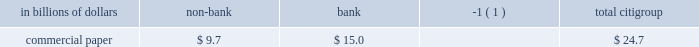Secured financing is primarily conducted through citi 2019s broker-dealer subsidiaries to facilitate customer matched-book activity and to efficiently fund a portion of the trading inventory .
Secured financing appears as a liability on citi 2019s consolidated balance sheet ( 201csecurities loaned or sold under agreements to repurchase 201d ) .
As of december 31 , 2010 , secured financing was $ 189.6 billion and averaged approximately $ 207 billion during the quarter ended december 31 , 2010 .
Secured financing at december 31 , 2010 increased by $ 35 billion from $ 154.3 billion at december 31 , 2009 .
During the same period , reverse repos and securities borrowing increased by $ 25 billion .
The majority of secured financing is collateralized by highly liquid government , government-backed and government agency securities .
This collateral comes primarily from citi 2019s trading assets and its secured lending , and is part of citi 2019s client matched-book activity given that citi both borrows and lends similar asset types on a secured basis .
The minority of secured financing is collateralized by less liquid collateral , and supports both citi 2019s trading assets as well as the business of secured lending to customers , which is also part of citi 2019s client matched-book activity .
The less liquid secured borrowing is carefully calibrated by asset quality , tenor and counterparty exposure , including those that might be sensitive to ratings stresses , in order to increase the reliability of the funding .
Citi believes there are several potential mitigants available to it in the event of stress on the secured financing markets for less liquid collateral .
Citi 2019s significant liquidity resources in its non-bank entities as of december 31 , 2010 , supplemented by collateralized liquidity transfers between entities , provide a cushion .
Within the matched-book activity , the secured lending positions , which are carefully managed in terms of collateral and tenor , could be unwound to provide additional liquidity under stress .
Citi also has excess funding capacity for less liquid collateral with existing counterparties that can be accessed during potential dislocation .
In addition , citi has the ability to adjust the size of select trading books to provide further mitigation .
At december 31 , 2010 , commercial paper outstanding for citigroup 2019s non- bank entities and bank subsidiaries , respectively , was as follows : in billions of dollars non-bank bank ( 1 ) citigroup .
( 1 ) includes $ 15 billion of commercial paper related to vies consolidated effective january 1 , 2010 with the adoption of sfas 166/167 .
Other short-term borrowings of approximately $ 54 billion ( as set forth in the secured financing and short-term borrowings table above ) include $ 42.4 billion of borrowings from banks and other market participants , which includes borrowings from the federal home loan banks .
This represented a decrease of approximately $ 11 billion as compared to year-end 2009 .
The average balance of borrowings from banks and other market participants for the quarter ended december 31 , 2010 was approximately $ 43 billion .
Other short-term borrowings also include $ 11.7 billion of broker borrowings at december 31 , 2010 , which averaged approximately $ 13 billion for the quarter ended december 31 , 2010 .
See notes 12 and 19 to the consolidated financial statements for further information on citigroup 2019s and its affiliates 2019 outstanding long-term debt and short-term borrowings .
Liquidity transfer between entities liquidity is generally transferable within the non-bank , subject to regulatory restrictions ( if any ) and standard legal terms .
Similarly , the non-bank can generally transfer excess liquidity into citi 2019s bank subsidiaries , such as citibank , n.a .
In addition , citigroup 2019s bank subsidiaries , including citibank , n.a. , can lend to the citigroup parent and broker-dealer in accordance with section 23a of the federal reserve act .
As of december 31 , 2010 , the amount available for lending under section 23a was approximately $ 26.6 billion , provided the funds are collateralized appropriately. .
What percentage of commercial paper outstanding as of december 31 , 2010 was for non-bank subsidiaries? 
Computations: (9.7 / 24.7)
Answer: 0.39271. 